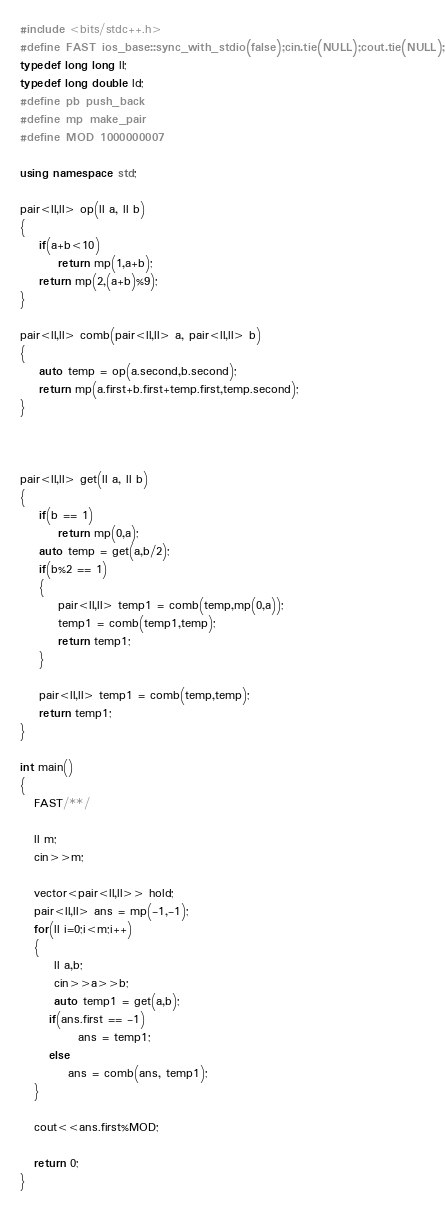<code> <loc_0><loc_0><loc_500><loc_500><_C++_>#include <bits/stdc++.h>
#define FAST ios_base::sync_with_stdio(false);cin.tie(NULL);cout.tie(NULL);
typedef long long ll;
typedef long double ld;
#define pb push_back
#define mp make_pair
#define MOD 1000000007

using namespace std;

pair<ll,ll> op(ll a, ll b)
{
    if(a+b<10)
        return mp(1,a+b);
    return mp(2,(a+b)%9);
}

pair<ll,ll> comb(pair<ll,ll> a, pair<ll,ll> b)
{
    auto temp = op(a.second,b.second);
    return mp(a.first+b.first+temp.first,temp.second);
}



pair<ll,ll> get(ll a, ll b)
{
    if(b == 1)
        return mp(0,a);
    auto temp = get(a,b/2);    
    if(b%2 == 1)
    {
        pair<ll,ll> temp1 = comb(temp,mp(0,a));
        temp1 = comb(temp1,temp);
        return temp1;
    }
    
    pair<ll,ll> temp1 = comb(temp,temp);
    return temp1;
}

int main()
{
   FAST/**/
   
   ll m;
   cin>>m;
   
   vector<pair<ll,ll>> hold;
   pair<ll,ll> ans = mp(-1,-1);
   for(ll i=0;i<m;i++)
   {
       ll a,b;
       cin>>a>>b;
       auto temp1 = get(a,b);
      if(ans.first == -1)
            ans = temp1;
      else
          ans = comb(ans, temp1);
   }
   
   cout<<ans.first%MOD;
   
   return 0;
}  
   </code> 